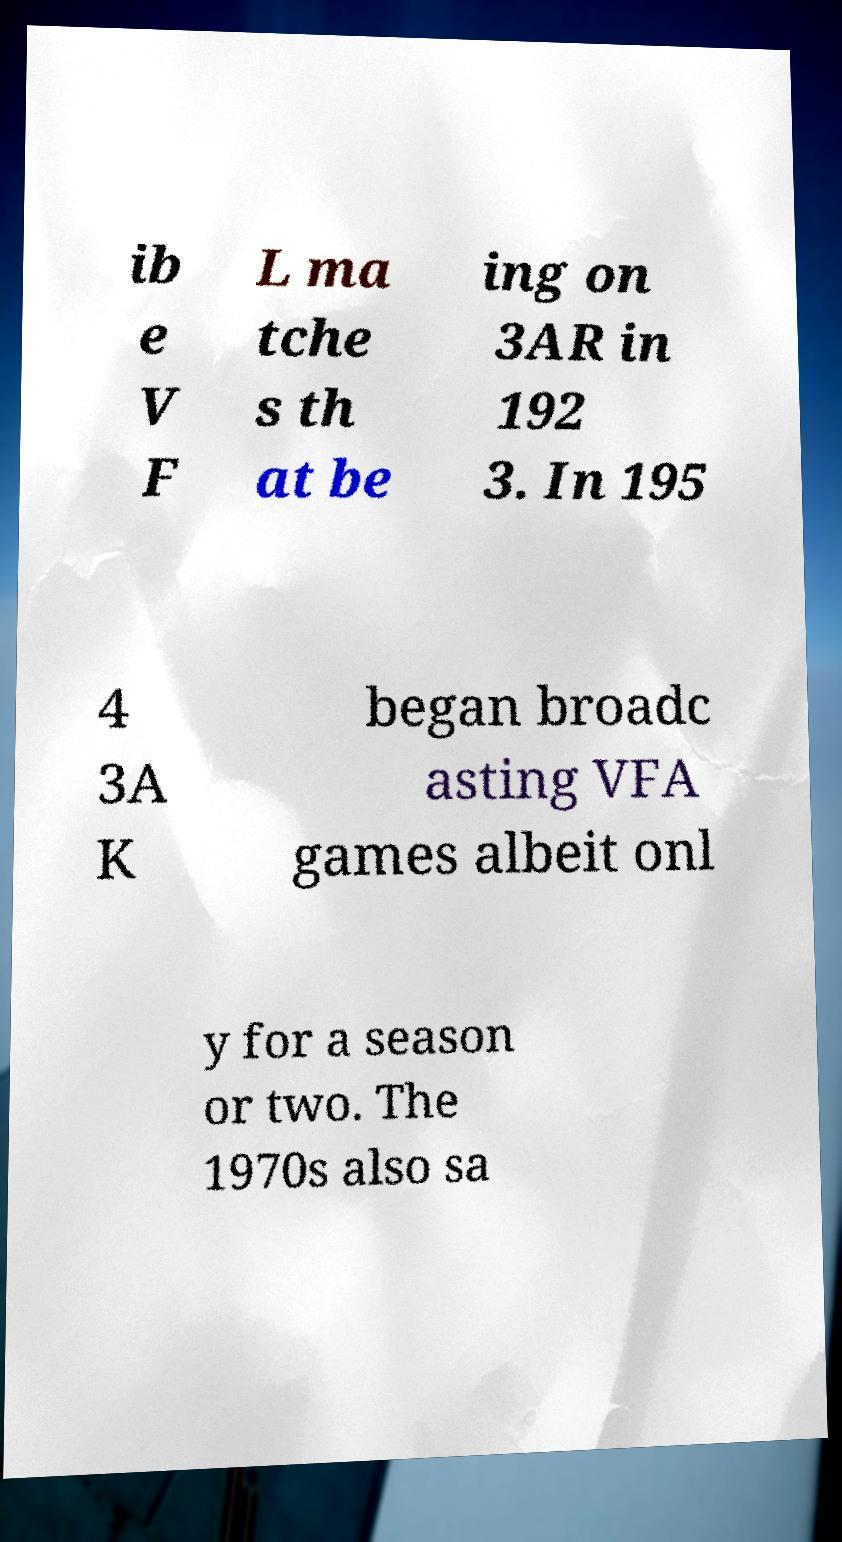There's text embedded in this image that I need extracted. Can you transcribe it verbatim? ib e V F L ma tche s th at be ing on 3AR in 192 3. In 195 4 3A K began broadc asting VFA games albeit onl y for a season or two. The 1970s also sa 